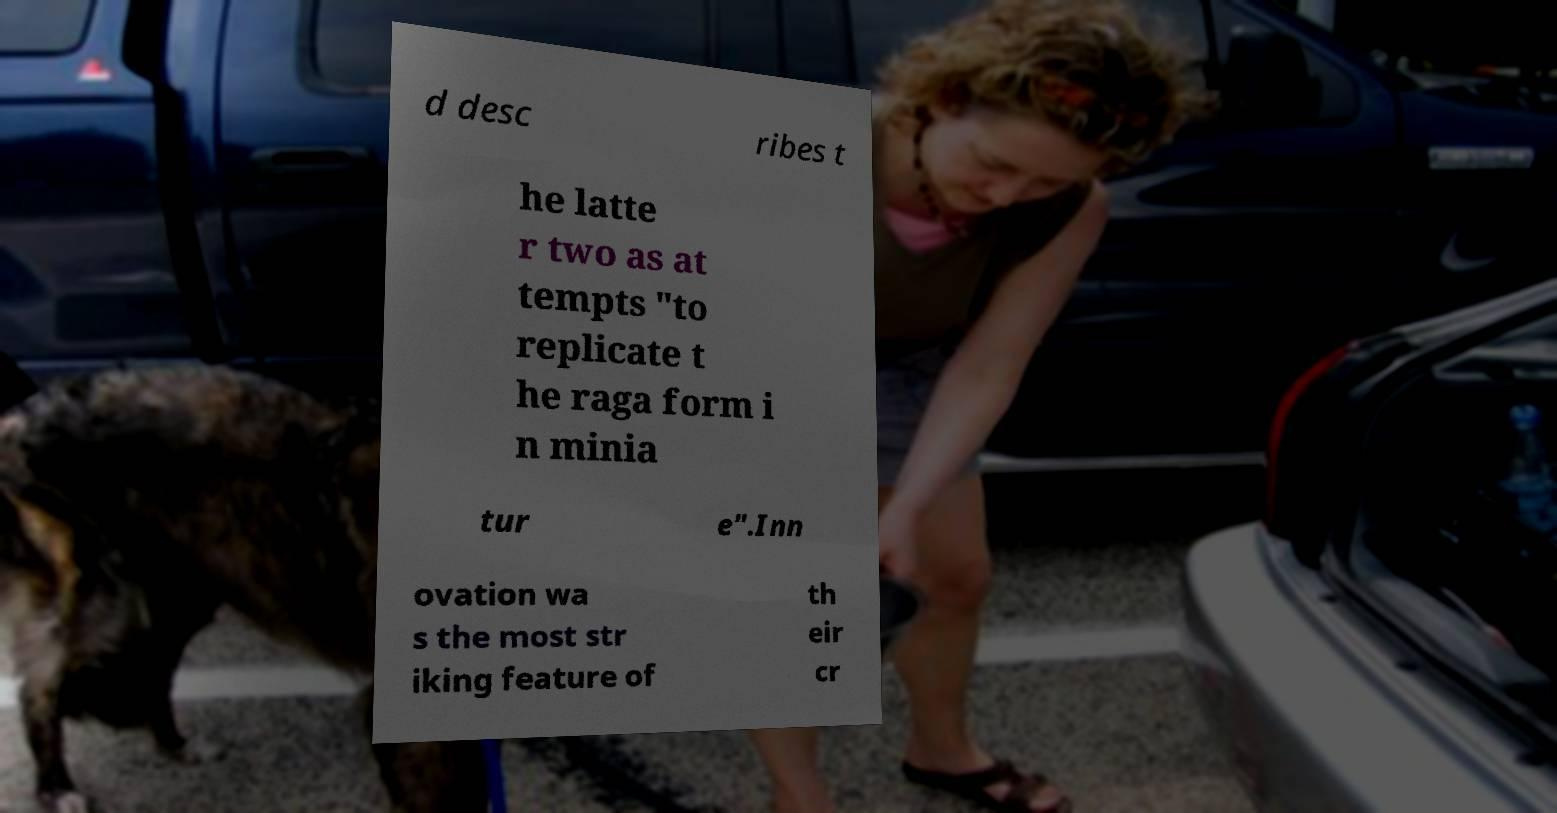For documentation purposes, I need the text within this image transcribed. Could you provide that? d desc ribes t he latte r two as at tempts "to replicate t he raga form i n minia tur e".Inn ovation wa s the most str iking feature of th eir cr 